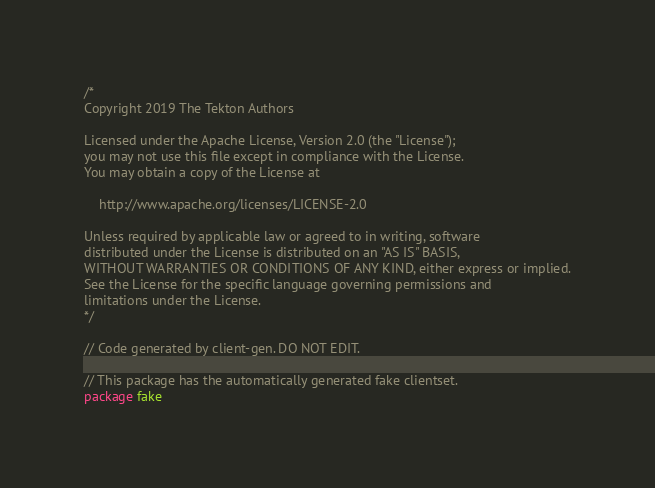<code> <loc_0><loc_0><loc_500><loc_500><_Go_>/*
Copyright 2019 The Tekton Authors

Licensed under the Apache License, Version 2.0 (the "License");
you may not use this file except in compliance with the License.
You may obtain a copy of the License at

    http://www.apache.org/licenses/LICENSE-2.0

Unless required by applicable law or agreed to in writing, software
distributed under the License is distributed on an "AS IS" BASIS,
WITHOUT WARRANTIES OR CONDITIONS OF ANY KIND, either express or implied.
See the License for the specific language governing permissions and
limitations under the License.
*/

// Code generated by client-gen. DO NOT EDIT.

// This package has the automatically generated fake clientset.
package fake
</code> 